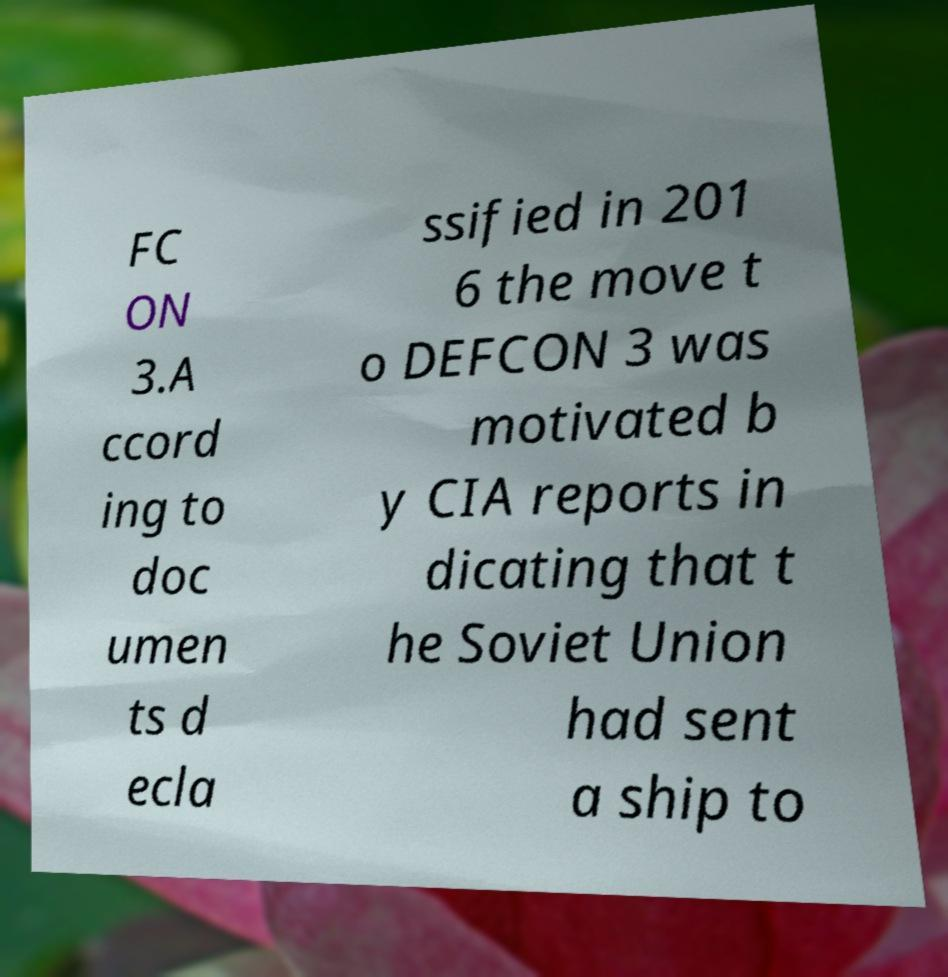There's text embedded in this image that I need extracted. Can you transcribe it verbatim? FC ON 3.A ccord ing to doc umen ts d ecla ssified in 201 6 the move t o DEFCON 3 was motivated b y CIA reports in dicating that t he Soviet Union had sent a ship to 